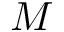<formula> <loc_0><loc_0><loc_500><loc_500>M</formula> 